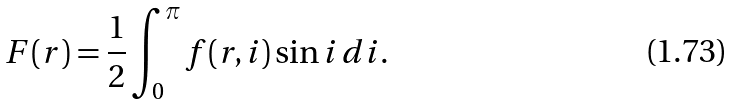Convert formula to latex. <formula><loc_0><loc_0><loc_500><loc_500>F ( r ) = \frac { 1 } { 2 } \int ^ { \pi } _ { 0 } f ( r , i ) \sin i \, d i .</formula> 